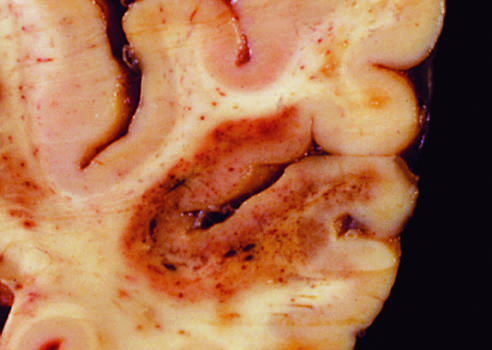what is present in the temporal lobe?
Answer the question using a single word or phrase. An infarct with punctate hemorrhages 